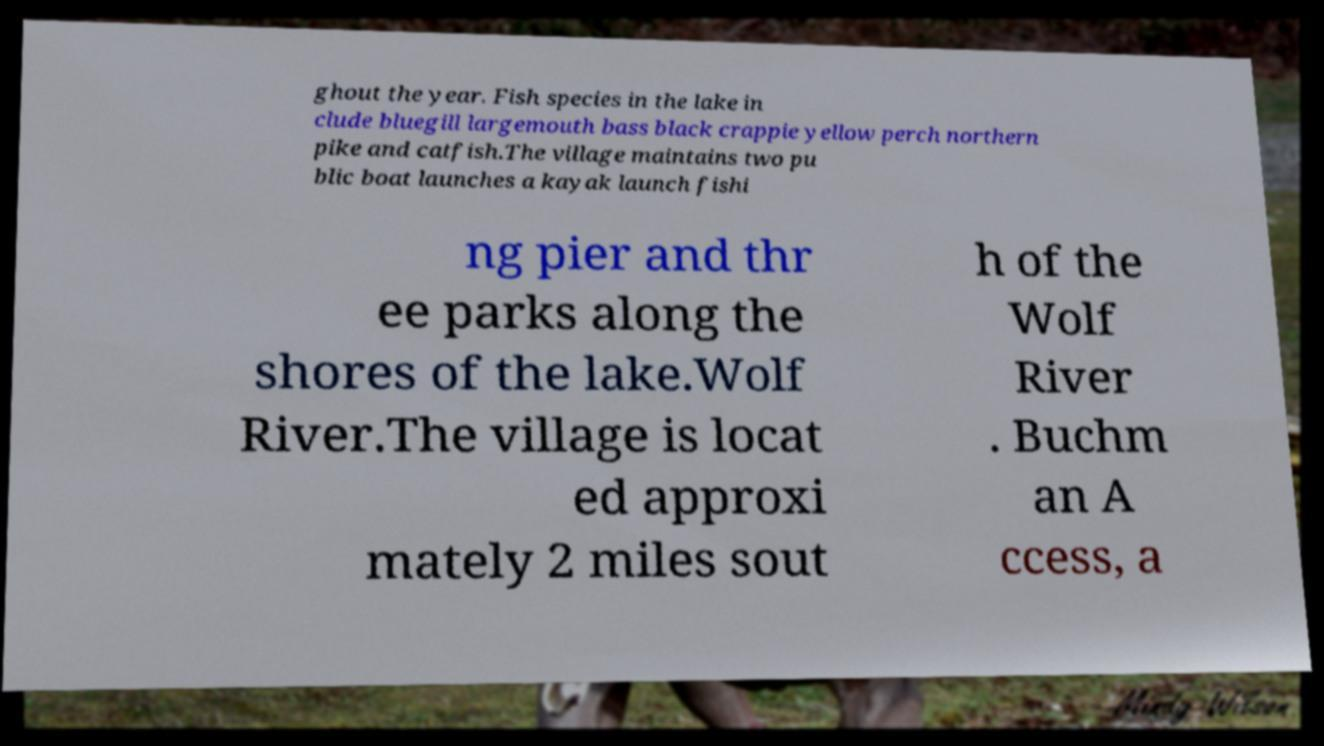Can you read and provide the text displayed in the image?This photo seems to have some interesting text. Can you extract and type it out for me? ghout the year. Fish species in the lake in clude bluegill largemouth bass black crappie yellow perch northern pike and catfish.The village maintains two pu blic boat launches a kayak launch fishi ng pier and thr ee parks along the shores of the lake.Wolf River.The village is locat ed approxi mately 2 miles sout h of the Wolf River . Buchm an A ccess, a 